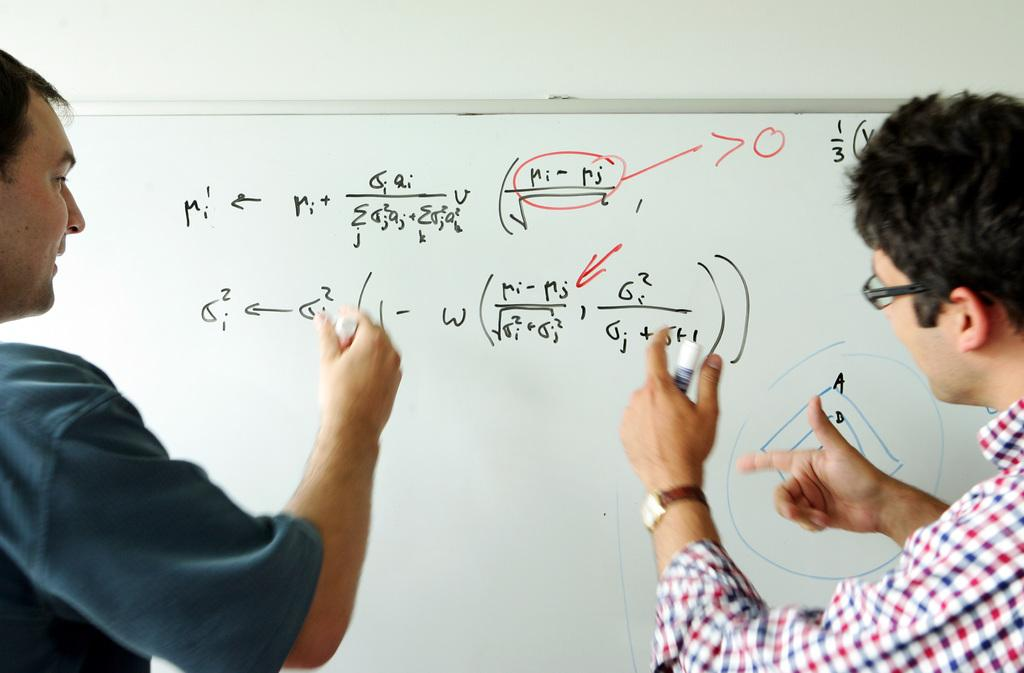<image>
Write a terse but informative summary of the picture. Two people writing on a white board with the letter M on the left. 